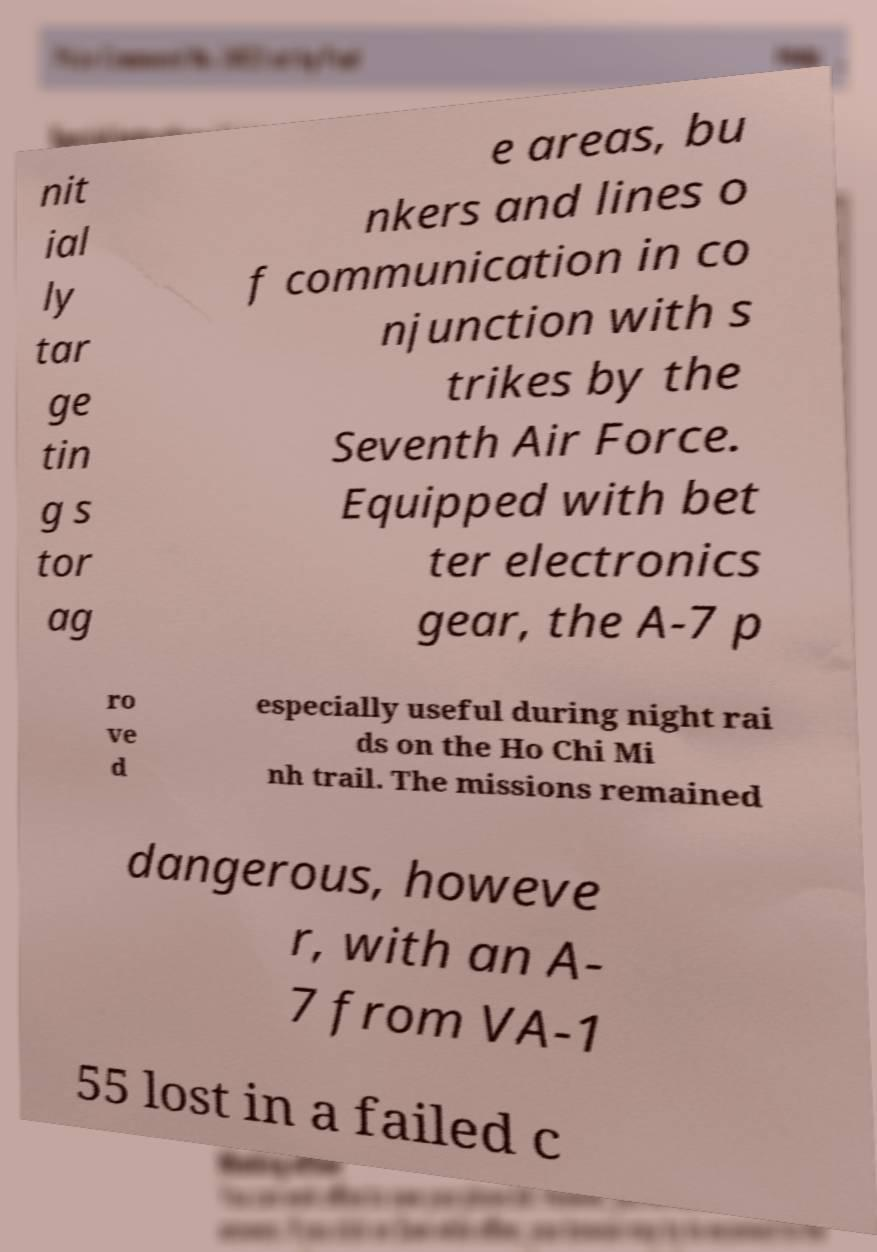Can you read and provide the text displayed in the image?This photo seems to have some interesting text. Can you extract and type it out for me? nit ial ly tar ge tin g s tor ag e areas, bu nkers and lines o f communication in co njunction with s trikes by the Seventh Air Force. Equipped with bet ter electronics gear, the A-7 p ro ve d especially useful during night rai ds on the Ho Chi Mi nh trail. The missions remained dangerous, howeve r, with an A- 7 from VA-1 55 lost in a failed c 